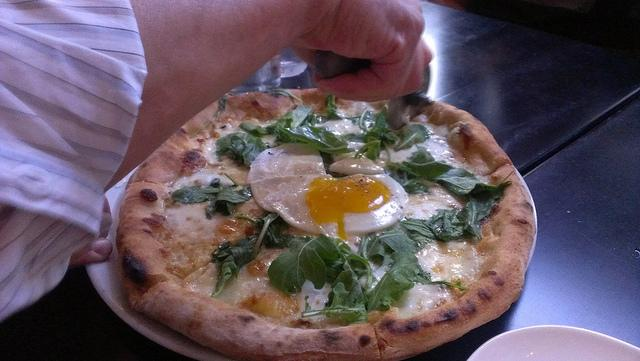What animal did the topmost ingredient come from?

Choices:
A) cow
B) pig
C) chicken
D) fish chicken 